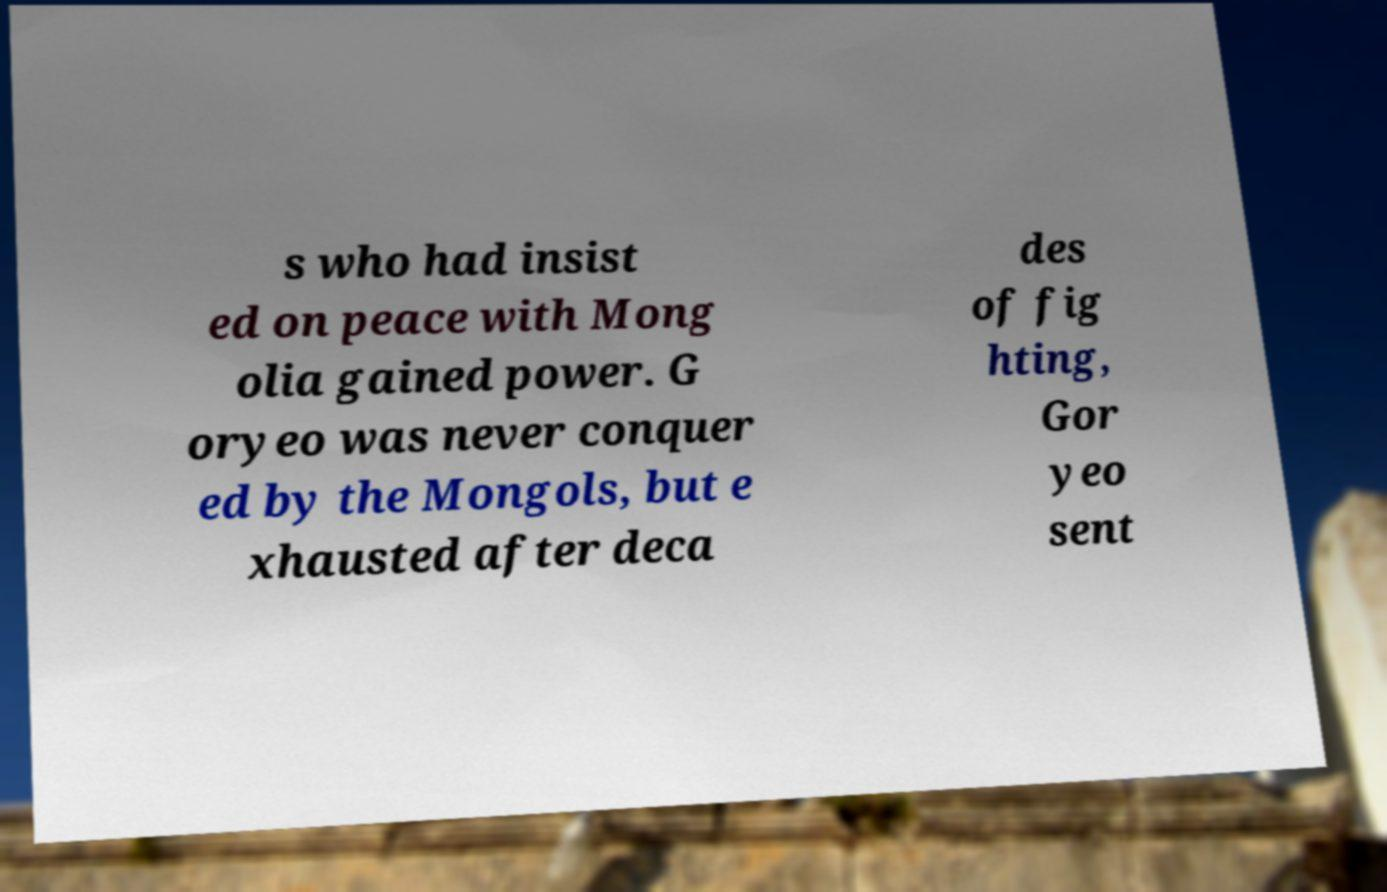Please read and relay the text visible in this image. What does it say? s who had insist ed on peace with Mong olia gained power. G oryeo was never conquer ed by the Mongols, but e xhausted after deca des of fig hting, Gor yeo sent 